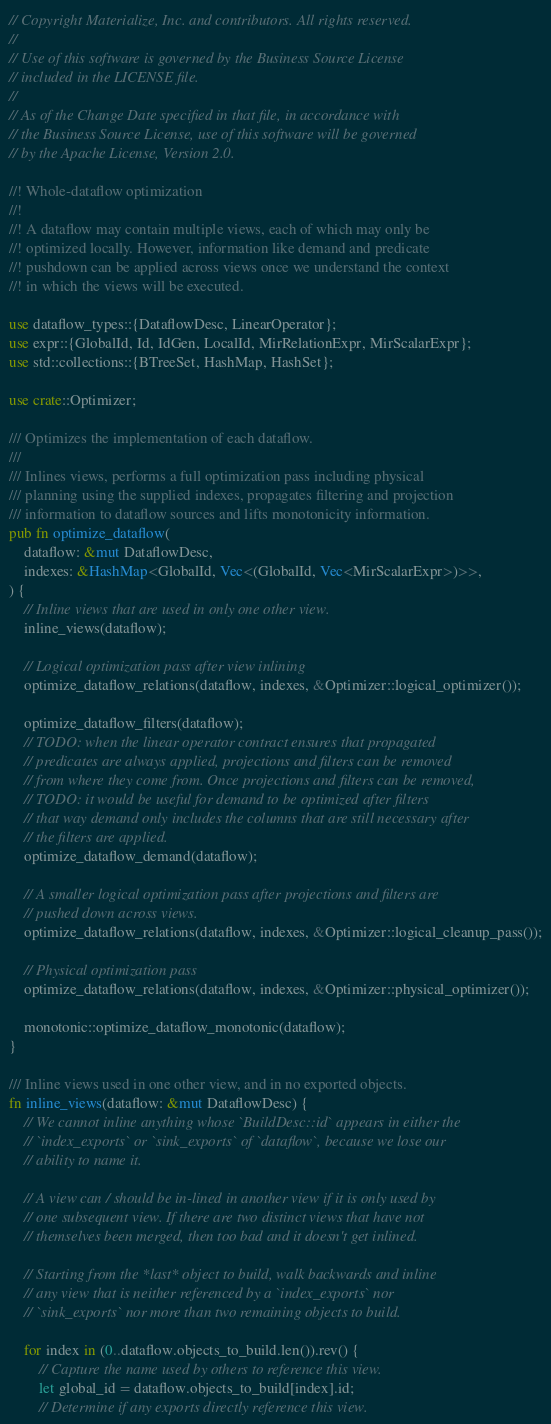Convert code to text. <code><loc_0><loc_0><loc_500><loc_500><_Rust_>// Copyright Materialize, Inc. and contributors. All rights reserved.
//
// Use of this software is governed by the Business Source License
// included in the LICENSE file.
//
// As of the Change Date specified in that file, in accordance with
// the Business Source License, use of this software will be governed
// by the Apache License, Version 2.0.

//! Whole-dataflow optimization
//!
//! A dataflow may contain multiple views, each of which may only be
//! optimized locally. However, information like demand and predicate
//! pushdown can be applied across views once we understand the context
//! in which the views will be executed.

use dataflow_types::{DataflowDesc, LinearOperator};
use expr::{GlobalId, Id, IdGen, LocalId, MirRelationExpr, MirScalarExpr};
use std::collections::{BTreeSet, HashMap, HashSet};

use crate::Optimizer;

/// Optimizes the implementation of each dataflow.
///
/// Inlines views, performs a full optimization pass including physical
/// planning using the supplied indexes, propagates filtering and projection
/// information to dataflow sources and lifts monotonicity information.
pub fn optimize_dataflow(
    dataflow: &mut DataflowDesc,
    indexes: &HashMap<GlobalId, Vec<(GlobalId, Vec<MirScalarExpr>)>>,
) {
    // Inline views that are used in only one other view.
    inline_views(dataflow);

    // Logical optimization pass after view inlining
    optimize_dataflow_relations(dataflow, indexes, &Optimizer::logical_optimizer());

    optimize_dataflow_filters(dataflow);
    // TODO: when the linear operator contract ensures that propagated
    // predicates are always applied, projections and filters can be removed
    // from where they come from. Once projections and filters can be removed,
    // TODO: it would be useful for demand to be optimized after filters
    // that way demand only includes the columns that are still necessary after
    // the filters are applied.
    optimize_dataflow_demand(dataflow);

    // A smaller logical optimization pass after projections and filters are
    // pushed down across views.
    optimize_dataflow_relations(dataflow, indexes, &Optimizer::logical_cleanup_pass());

    // Physical optimization pass
    optimize_dataflow_relations(dataflow, indexes, &Optimizer::physical_optimizer());

    monotonic::optimize_dataflow_monotonic(dataflow);
}

/// Inline views used in one other view, and in no exported objects.
fn inline_views(dataflow: &mut DataflowDesc) {
    // We cannot inline anything whose `BuildDesc::id` appears in either the
    // `index_exports` or `sink_exports` of `dataflow`, because we lose our
    // ability to name it.

    // A view can / should be in-lined in another view if it is only used by
    // one subsequent view. If there are two distinct views that have not
    // themselves been merged, then too bad and it doesn't get inlined.

    // Starting from the *last* object to build, walk backwards and inline
    // any view that is neither referenced by a `index_exports` nor
    // `sink_exports` nor more than two remaining objects to build.

    for index in (0..dataflow.objects_to_build.len()).rev() {
        // Capture the name used by others to reference this view.
        let global_id = dataflow.objects_to_build[index].id;
        // Determine if any exports directly reference this view.</code> 